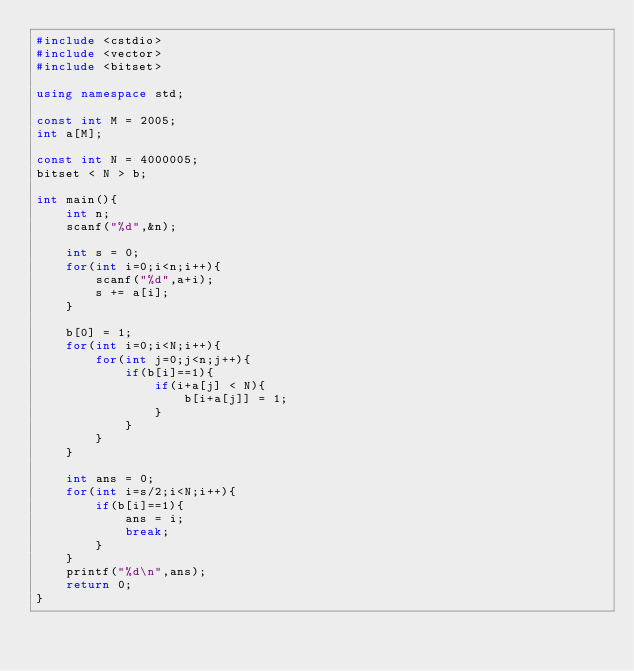<code> <loc_0><loc_0><loc_500><loc_500><_C++_>#include <cstdio>
#include <vector>
#include <bitset>

using namespace std;

const int M = 2005;
int a[M];

const int N = 4000005;
bitset < N > b;

int main(){
    int n;
    scanf("%d",&n);
    
    int s = 0;
    for(int i=0;i<n;i++){
        scanf("%d",a+i);
        s += a[i];
    }
    
    b[0] = 1;
    for(int i=0;i<N;i++){
        for(int j=0;j<n;j++){
            if(b[i]==1){
                if(i+a[j] < N){
                    b[i+a[j]] = 1;
                }   
            }
        }
    }
    
    int ans = 0;
    for(int i=s/2;i<N;i++){
        if(b[i]==1){
            ans = i;
            break;
        }
    }
    printf("%d\n",ans);
    return 0;
}</code> 